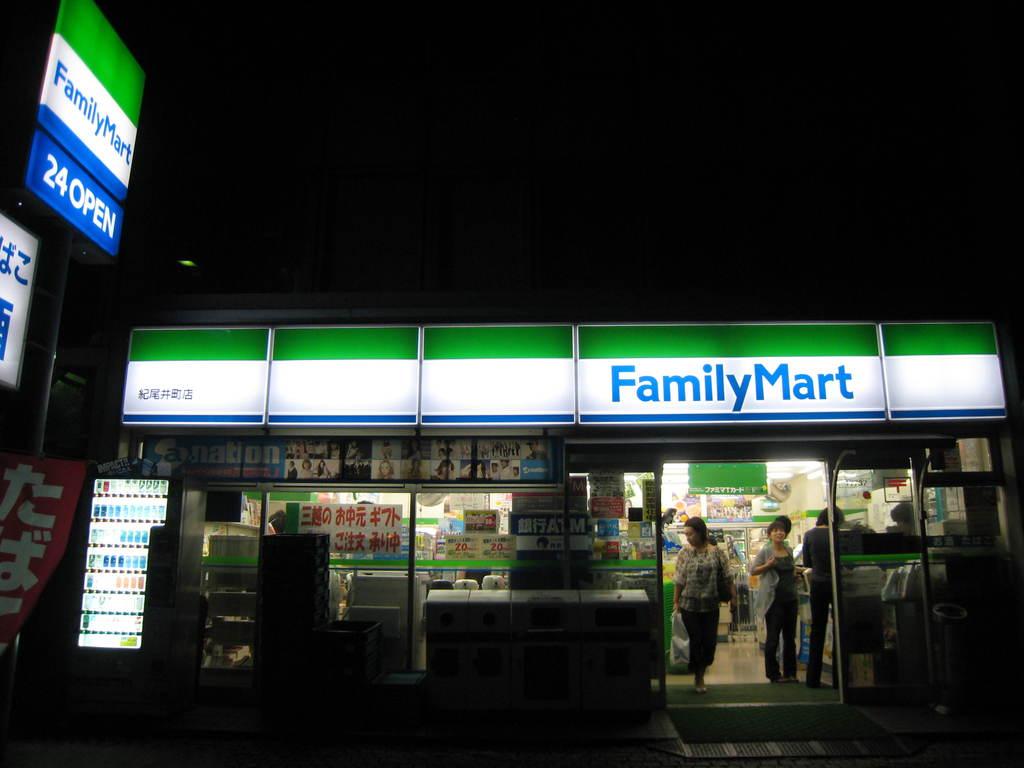How long are they open?
Make the answer very short. 24 hours. 